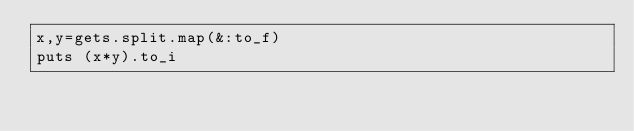<code> <loc_0><loc_0><loc_500><loc_500><_Ruby_>x,y=gets.split.map(&:to_f)
puts (x*y).to_i
</code> 